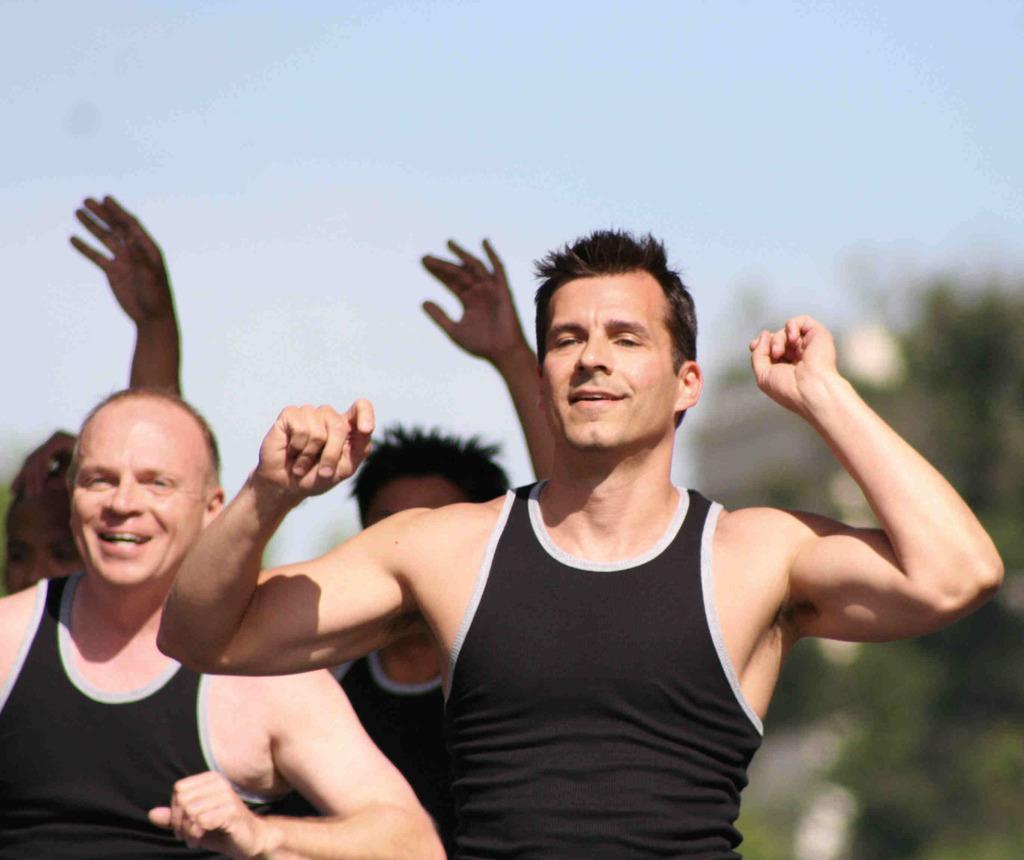Please provide a concise description of this image. In this image I can see two persons wearing black colored dresses are standing. In the background I can see few other persons, few trees and the sky. 